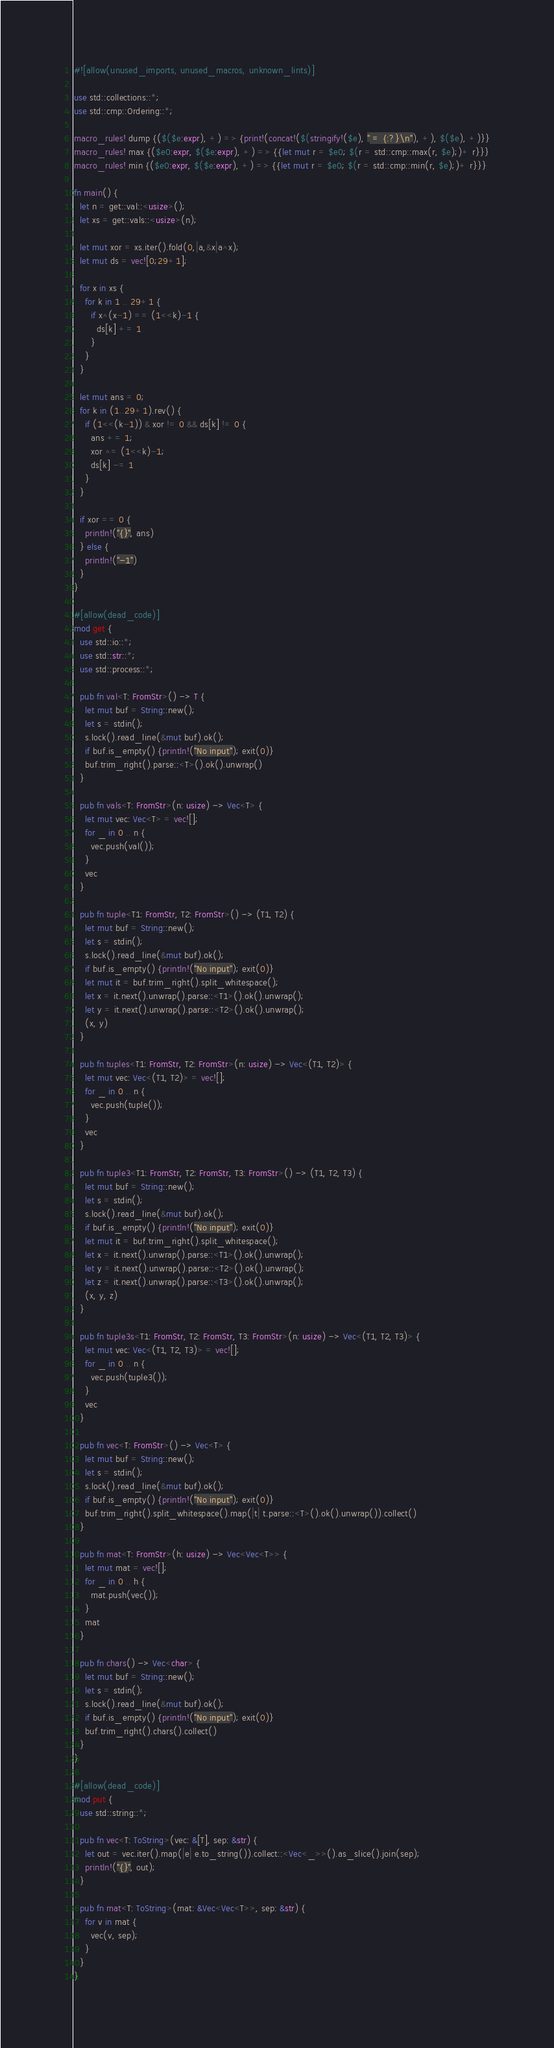<code> <loc_0><loc_0><loc_500><loc_500><_Rust_>#![allow(unused_imports, unused_macros, unknown_lints)]

use std::collections::*;
use std::cmp::Ordering::*;

macro_rules! dump {($($e:expr), +) => {print!(concat!($(stringify!($e), " = {:?}\n"), +), $($e), +)}}
macro_rules! max {($e0:expr, $($e:expr), +) => {{let mut r = $e0; $(r = std::cmp::max(r, $e);)+ r}}}
macro_rules! min {($e0:expr, $($e:expr), +) => {{let mut r = $e0; $(r = std::cmp::min(r, $e);)+ r}}}

fn main() {
  let n = get::val::<usize>();
  let xs = get::vals::<usize>(n);

  let mut xor = xs.iter().fold(0,|a,&x|a^x);
  let mut ds = vec![0;29+1];
  
  for x in xs {
    for k in 1 .. 29+1 {
      if x^(x-1) == (1<<k)-1 {
        ds[k] += 1
      }
    }
  }
  
  let mut ans = 0;
  for k in (1..29+1).rev() {
    if (1<<(k-1)) & xor != 0 && ds[k] != 0 {
      ans += 1;
      xor ^= (1<<k)-1;
      ds[k] -= 1
    }
  }
  
  if xor == 0 {
    println!("{}", ans)
  } else {
    println!("-1")
  }
}

#[allow(dead_code)]
mod get {
  use std::io::*;
  use std::str::*;
  use std::process::*;

  pub fn val<T: FromStr>() -> T {
    let mut buf = String::new();
    let s = stdin();
    s.lock().read_line(&mut buf).ok();
    if buf.is_empty() {println!("No input"); exit(0)}
    buf.trim_right().parse::<T>().ok().unwrap()
  }

  pub fn vals<T: FromStr>(n: usize) -> Vec<T> {
    let mut vec: Vec<T> = vec![];
    for _ in 0 .. n {
      vec.push(val());
    }
    vec
  }

  pub fn tuple<T1: FromStr, T2: FromStr>() -> (T1, T2) {
    let mut buf = String::new();
    let s = stdin();
    s.lock().read_line(&mut buf).ok();
    if buf.is_empty() {println!("No input"); exit(0)}
    let mut it = buf.trim_right().split_whitespace();
    let x = it.next().unwrap().parse::<T1>().ok().unwrap();
    let y = it.next().unwrap().parse::<T2>().ok().unwrap();
    (x, y)
  }

  pub fn tuples<T1: FromStr, T2: FromStr>(n: usize) -> Vec<(T1, T2)> {
    let mut vec: Vec<(T1, T2)> = vec![];
    for _ in 0 .. n {
      vec.push(tuple());
    }
    vec
  }

  pub fn tuple3<T1: FromStr, T2: FromStr, T3: FromStr>() -> (T1, T2, T3) {
    let mut buf = String::new();
    let s = stdin();
    s.lock().read_line(&mut buf).ok();
    if buf.is_empty() {println!("No input"); exit(0)}
    let mut it = buf.trim_right().split_whitespace();
    let x = it.next().unwrap().parse::<T1>().ok().unwrap();
    let y = it.next().unwrap().parse::<T2>().ok().unwrap();
    let z = it.next().unwrap().parse::<T3>().ok().unwrap();
    (x, y, z)
  }

  pub fn tuple3s<T1: FromStr, T2: FromStr, T3: FromStr>(n: usize) -> Vec<(T1, T2, T3)> {
    let mut vec: Vec<(T1, T2, T3)> = vec![];
    for _ in 0 .. n {
      vec.push(tuple3());
    }
    vec
  }

  pub fn vec<T: FromStr>() -> Vec<T> {
    let mut buf = String::new();
    let s = stdin();
    s.lock().read_line(&mut buf).ok();
    if buf.is_empty() {println!("No input"); exit(0)}
    buf.trim_right().split_whitespace().map(|t| t.parse::<T>().ok().unwrap()).collect()
  }

  pub fn mat<T: FromStr>(h: usize) -> Vec<Vec<T>> {
    let mut mat = vec![];
    for _ in 0 .. h {
      mat.push(vec());
    }
    mat
  }

  pub fn chars() -> Vec<char> {
    let mut buf = String::new();
    let s = stdin();
    s.lock().read_line(&mut buf).ok();
    if buf.is_empty() {println!("No input"); exit(0)}
    buf.trim_right().chars().collect()
  }
}

#[allow(dead_code)]
mod put {
  use std::string::*;

  pub fn vec<T: ToString>(vec: &[T], sep: &str) {
    let out = vec.iter().map(|e| e.to_string()).collect::<Vec<_>>().as_slice().join(sep);
    println!("{}", out);
  }

  pub fn mat<T: ToString>(mat: &Vec<Vec<T>>, sep: &str) {
    for v in mat {
      vec(v, sep);
    }
  }
}</code> 